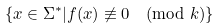<formula> <loc_0><loc_0><loc_500><loc_500>\{ x \in \Sigma ^ { * } | f ( x ) \not \equiv 0 \pmod { k } \}</formula> 